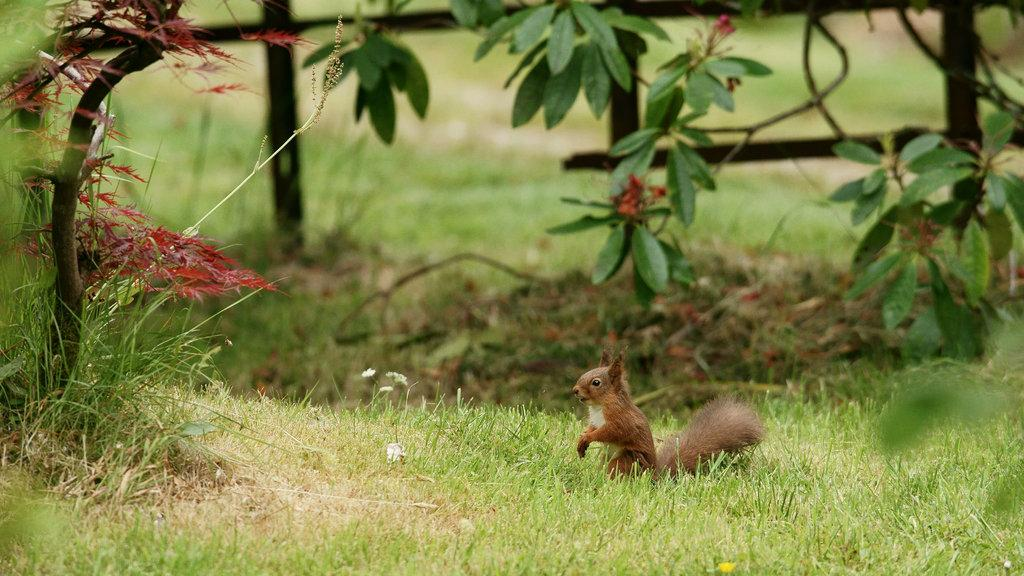What animal can be seen on the ground in the image? There is a squirrel on the ground in the image. What type of vegetation is present in the image? There are trees in the image. What is the natural setting visible in the background of the image? The background of the image includes grass. How would you describe the clarity of the image? The image is blurry. What type of trade is being conducted by the robin in the image? There is no robin present in the image; it features a squirrel on the ground. Can you describe the harbor visible in the image? There is no harbor present in the image; it features a squirrel on the ground, trees, and grassy background. 